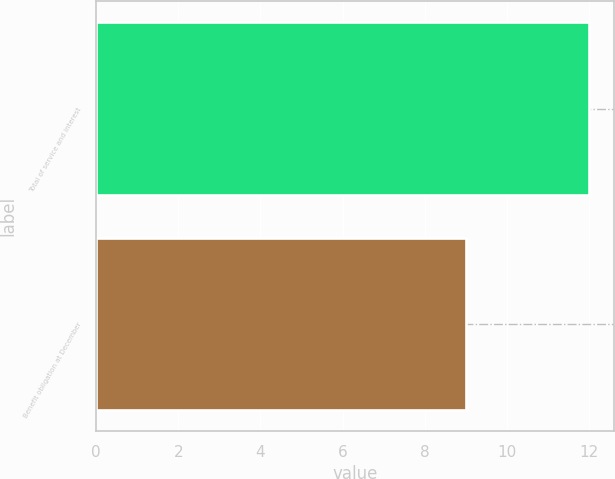Convert chart. <chart><loc_0><loc_0><loc_500><loc_500><bar_chart><fcel>Total of service and interest<fcel>Benefit obligation at December<nl><fcel>12<fcel>9<nl></chart> 